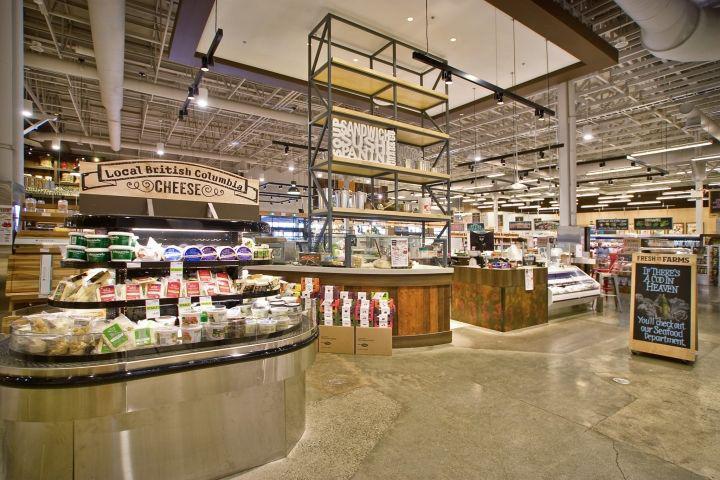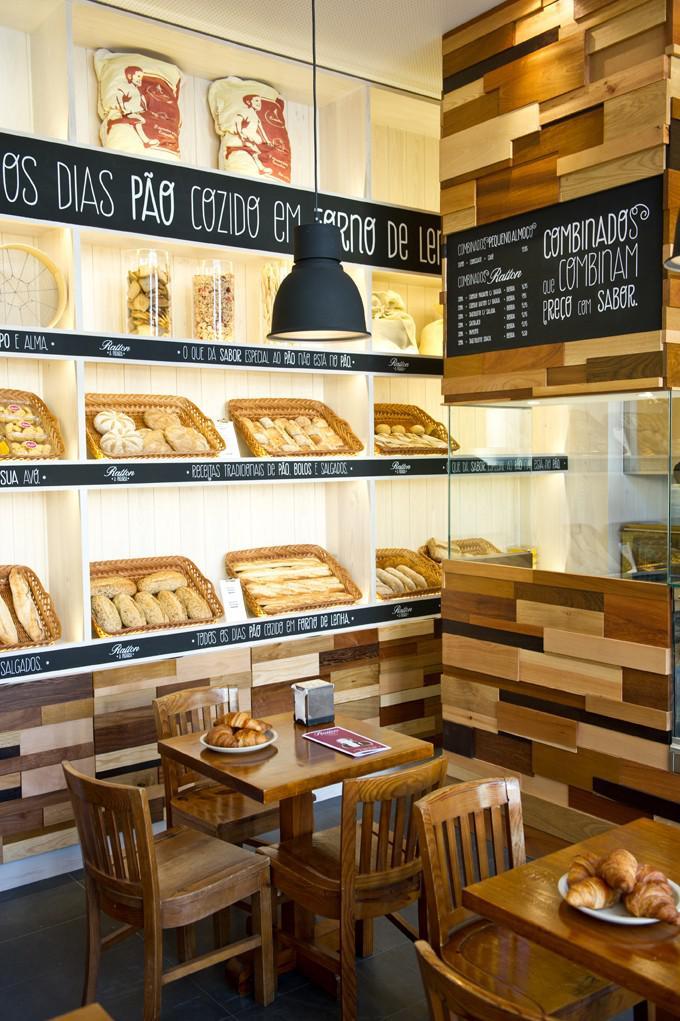The first image is the image on the left, the second image is the image on the right. Evaluate the accuracy of this statement regarding the images: "One of the places has a wooden floor.". Is it true? Answer yes or no. No. The first image is the image on the left, the second image is the image on the right. Assess this claim about the two images: "Wooden tables and chairs for patrons to sit and eat are shown in one image.". Correct or not? Answer yes or no. Yes. 